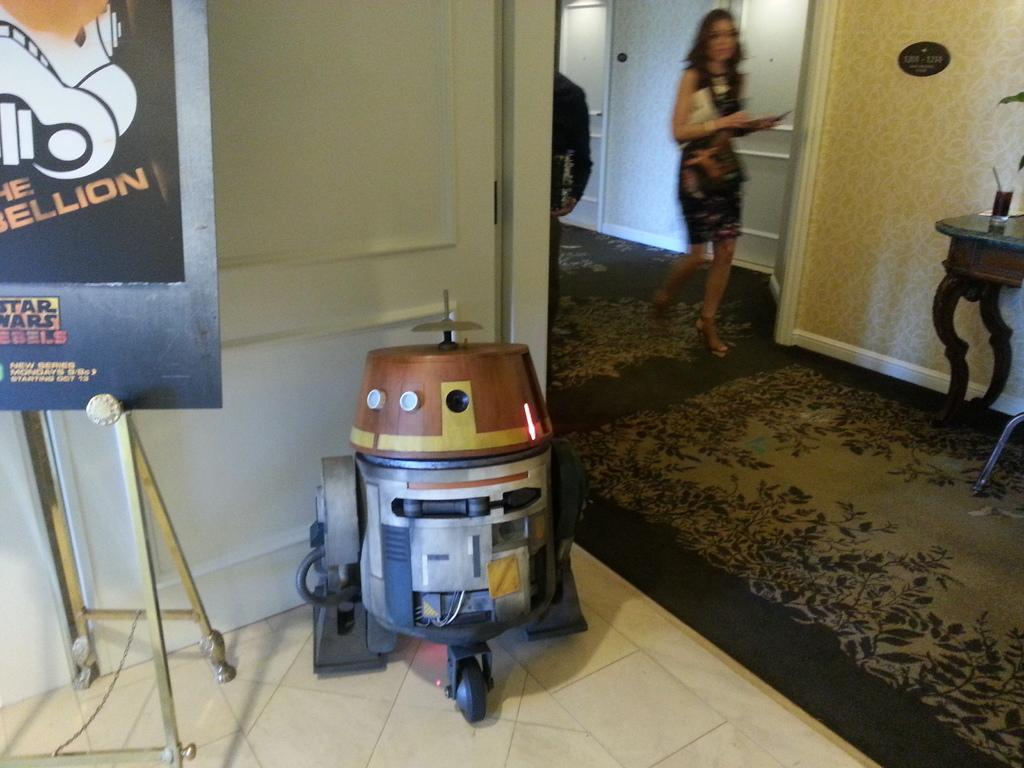<image>
Create a compact narrative representing the image presented. A Star Wars poster and a display of a Star Wars robot. 